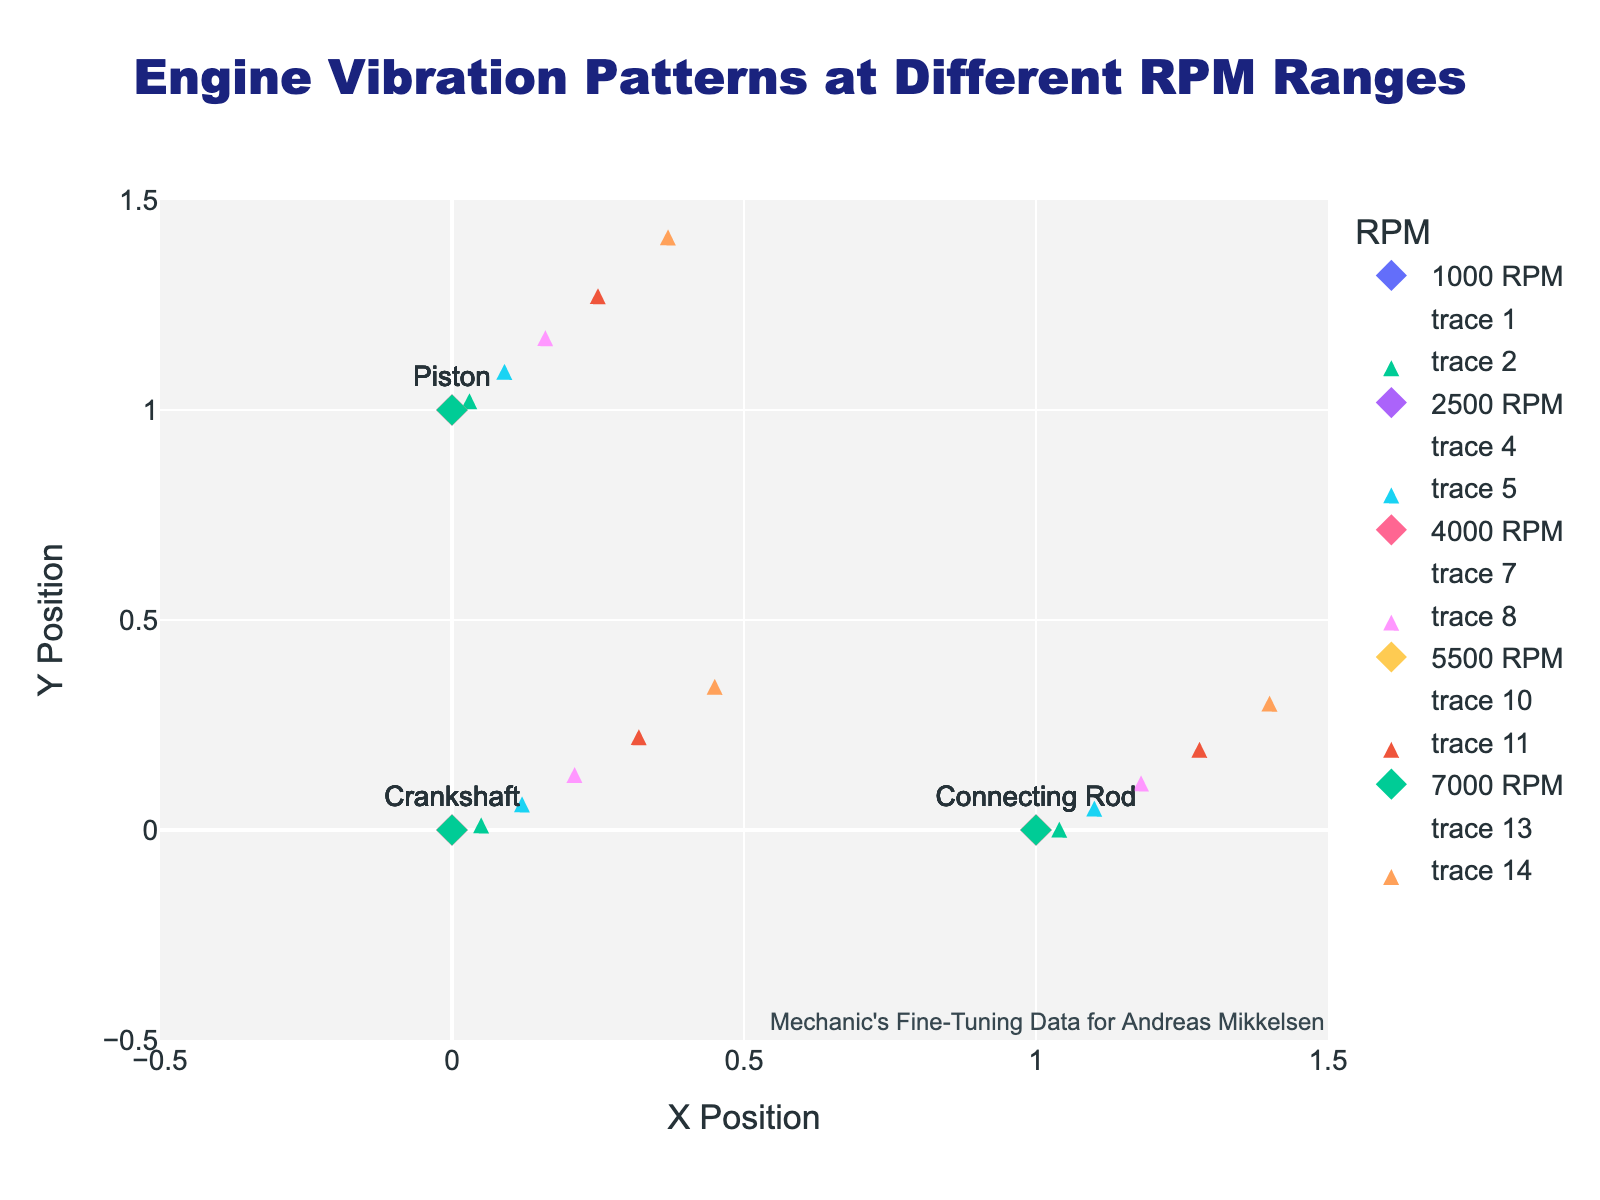What is the title of the quiver plot? The title can be found at the top center of the plot. It is displayed prominently in a larger font.
Answer: Engine Vibration Patterns at Different RPM Ranges How many RPM ranges are represented in the plot? The number of unique RPM values in the legend or the color-coded components can be counted.
Answer: 5 Which engine component has the highest vibration at 5500 RPM? Look at the markers and arrows at 5500 RPM. Compare the vibration vectors of Crankshaft, Connecting Rod, and Piston to see which has the highest length.
Answer: Crankshaft What are the X and Y vibrational coordinates for the Connecting Rod at 4000 RPM? Hover over or reference the data associated with the Connecting Rod at 4000 RPM to find its X and Y vibration coordinates.
Answer: (1.8, 1.3) Which RPM range shows the greatest overall vibration magnitude for the Crankshaft? Compare the lengths of the vibration vectors for the Crankshaft at different RPMs. The longest arrow corresponds to the highest magnitude.
Answer: 7000 RPM How does the Piston's vibration at 7000 RPM compare to its vibration at 2500 RPM? Compare the lengths and directions of the arrows representing Piston's vibration at 7000 RPM and 2500 RPM.
Answer: Higher at 7000 RPM What is the sum of the X vibrations for the Piston across all RPM ranges? Sum the X vibration values for the Piston from the data for all RPM values: 0.3 + 0.9 + 1.6 + 2.5 + 3.7.
Answer: 9.0 Which component has the least vibration at 1000 RPM? Look at the vectors at 1000 RPM and compare their lengths to identify the shortest one.
Answer: Piston What is the average Y vibration for the Crankshaft across all RPMs? Add the Y vibration values for the Crankshaft across all RPMs and then divide by the number of measurements (0.3 + 0.8 + 1.5 + 2.4 + 3.6) / 5.
Answer: 1.72 At 2500 RPM, how do the vibration directions of the Crankshaft and Piston differ? Observe the angles of the arrows for the Crankshaft and Piston at 2500 RPM to evaluate their differences.
Answer: Crankshaft's vibration is more horizontal Which component shows more consistent vibration patterns across different RPM ranges? Evaluate the consistency by comparing the vibration vectors' lengths and directions across different RPM ranges for each component.
Answer: Connecting Rod 